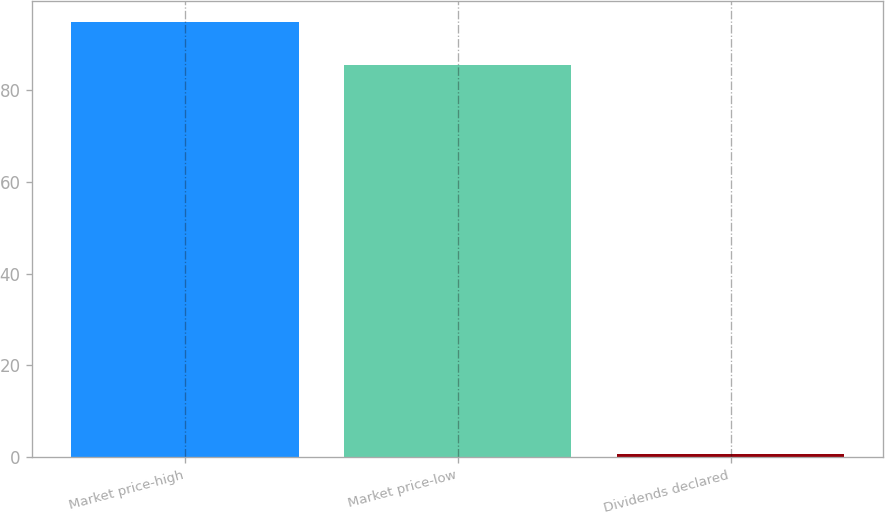<chart> <loc_0><loc_0><loc_500><loc_500><bar_chart><fcel>Market price-high<fcel>Market price-low<fcel>Dividends declared<nl><fcel>94.78<fcel>85.45<fcel>0.6<nl></chart> 